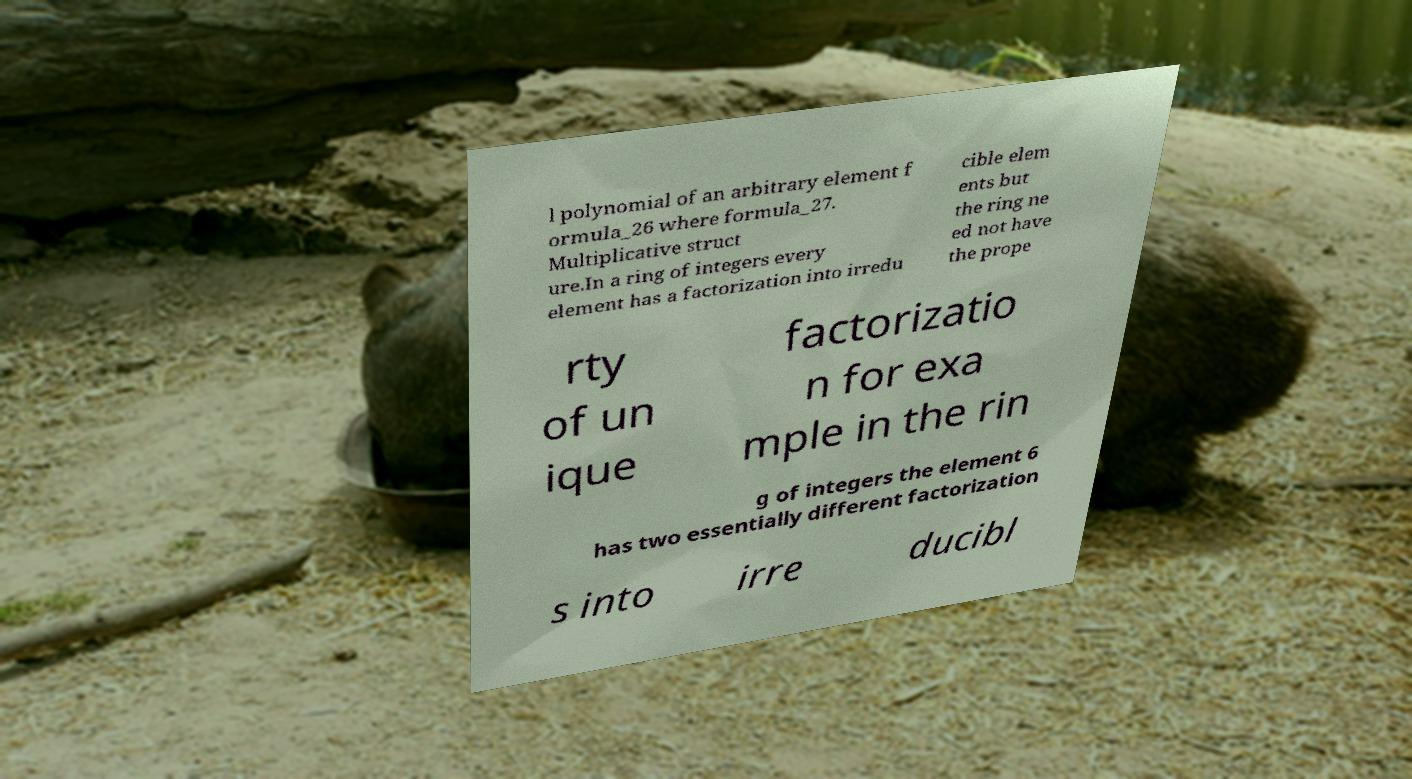Please read and relay the text visible in this image. What does it say? l polynomial of an arbitrary element f ormula_26 where formula_27. Multiplicative struct ure.In a ring of integers every element has a factorization into irredu cible elem ents but the ring ne ed not have the prope rty of un ique factorizatio n for exa mple in the rin g of integers the element 6 has two essentially different factorization s into irre ducibl 